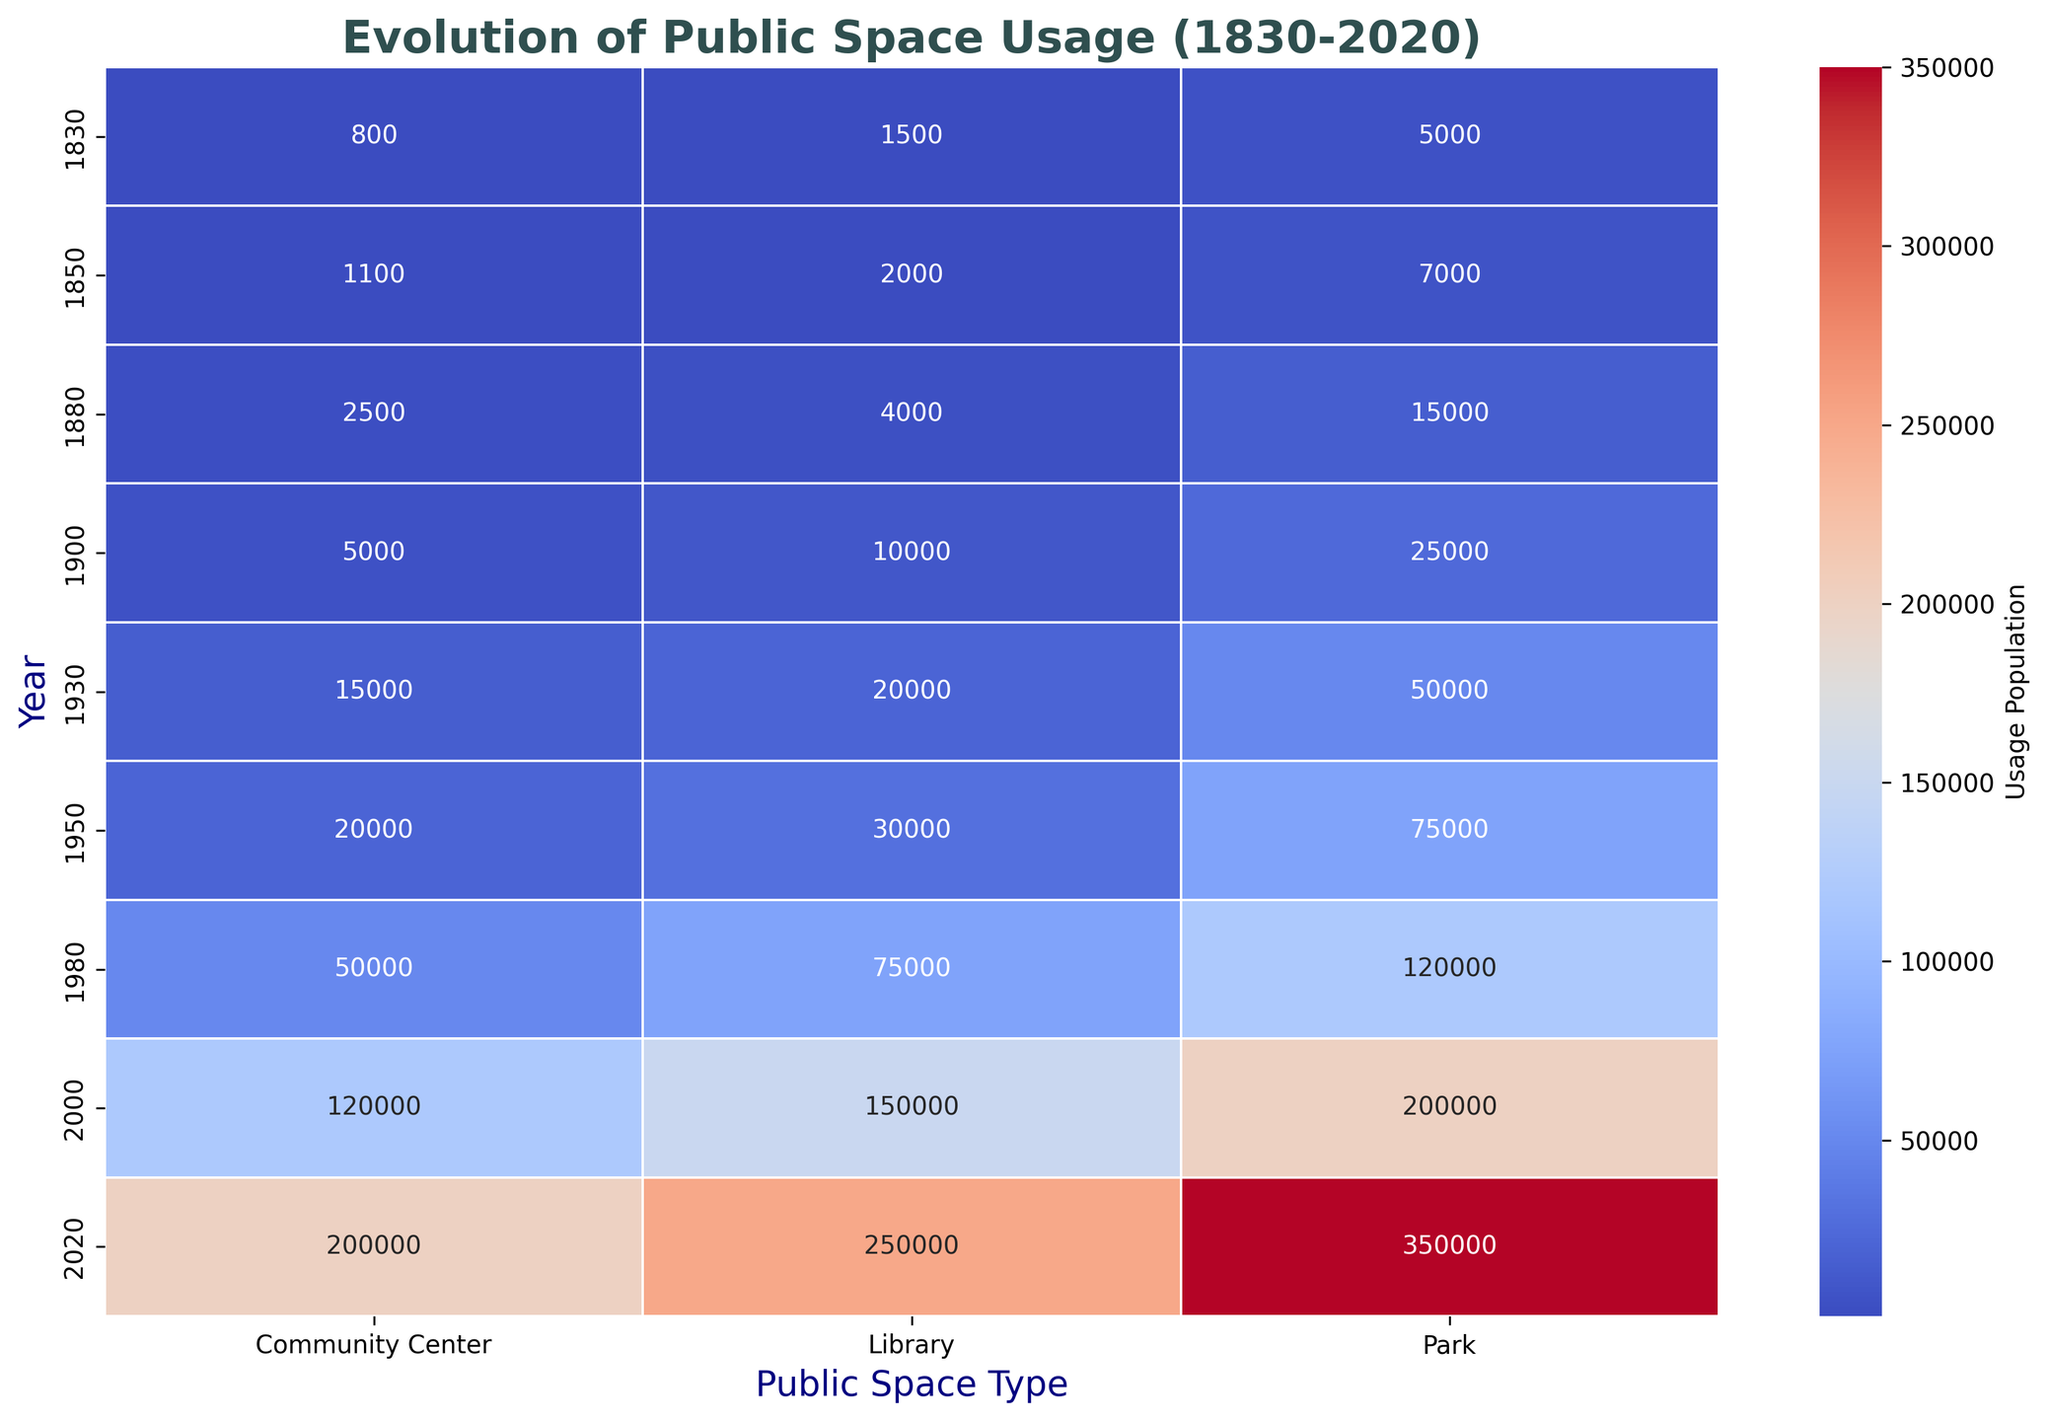What year had the highest usage population for parks in New York? Look at the heatmap under the 'Park' column for New York and identify the year with the highest value. The highest usage population for parks in New York is 350,000 in 2020.
Answer: 2020 Which public space type in Boston had the most significant increase in usage population between 1830 and 2020? Compare the values for Parks, Libraries, and Community Centers in Boston for the years 1830 and 2020. Libraries increased from 1500 to 250,000, which is the most significant increase.
Answer: Library Was there a larger increase in park usage population in New York between 1950 and 1980 or between 1980 and 2000? Subtract the park usage in New York for 1950 from 1980, and for 1980 from 2000. The increase between 1950 and 1980 is 120,000 - 50,000 = 70,000. The increase between 1980 and 2000 is 200,000 - 120,000 = 80,000. Thus, the latter period had a larger increase.
Answer: 1980 to 2000 What is the average usage population for community centers in Philadelphia across all recorded years? Sum the usage population values for community centers in Philadelphia and divide by the number of recorded years (1830, 1880, 1930, 1980, 2020). The sum is 800 + 2500 + 15000 + 50000 + 200000 = 268,300. Dividing by 5 gives the average.
Answer: 53,660 In which year was the usage population for libraries highest in San Francisco? Locate the highest value in the heatmap under the 'Library' column for San Francisco. The highest value is 250,000 in 2020.
Answer: 2020 By what factor did the community center usage in Baltimore increase from 1850 to 2020? Divide the usage population in 2020 by the usage population in 1850 for community centers in Baltimore. The increase is a factor of 200,000 / 1,100 ≈ 181.82.
Answer: ≈ 181.82 Which city showed the lowest usage population for parks in 1830? Look at the heatmap under the 'Park' column for the year 1830 and identify the lowest value among the cities listed. New York has the record with 5000.
Answer: New York What is the range of the usage population for libraries in Boston from 1830 to 2020? Identify the minimum and maximum values for libraries in Boston. The minimum is 1500 in 1830, and the maximum is 250,000 in 2020. The range is 250,000 - 1500 = 248,500.
Answer: 248,500 Is the usage population for parks in Chicago greater in 2000 or 2020? Compare the usage population for parks in Chicago for the years 2000 and 2020. The value in 2000 is 200,000 and in 2020 is not provided, so we can infer 2000 is the highest recorded.
Answer: 2000 Which public space type shows the most usage increase in New York from 1930 to 2020? Compare the usage increase for parks, libraries, and community centers in New York between 1930 and 2020. Parks see an increase from 50,000 to 350,000, which is the most significant increase among the types.
Answer: Park 